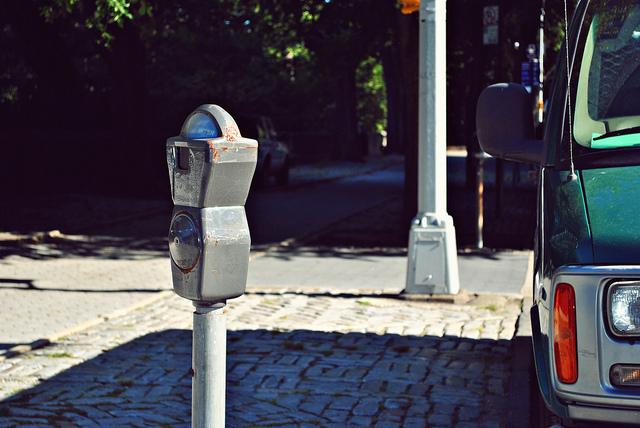What must be inserted into the machine?
Answer briefly. Coins. What is the meter on the left?
Concise answer only. Parking meter. Is the vehicle on the right a compact car?
Be succinct. No. 